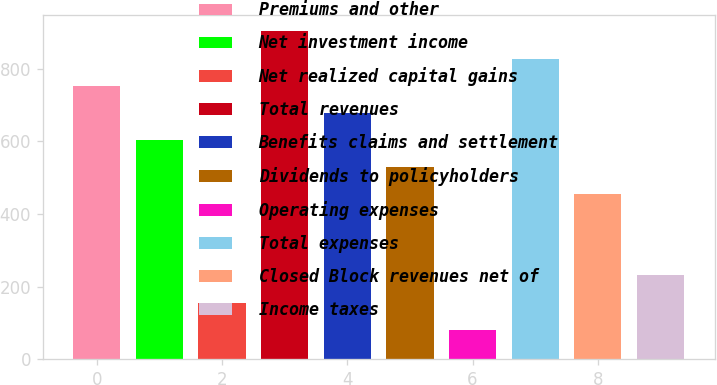Convert chart. <chart><loc_0><loc_0><loc_500><loc_500><bar_chart><fcel>Premiums and other<fcel>Net investment income<fcel>Net realized capital gains<fcel>Total revenues<fcel>Benefits claims and settlement<fcel>Dividends to policyholders<fcel>Operating expenses<fcel>Total expenses<fcel>Closed Block revenues net of<fcel>Income taxes<nl><fcel>753.7<fcel>604.28<fcel>156.02<fcel>903.12<fcel>678.99<fcel>529.57<fcel>81.31<fcel>828.41<fcel>454.86<fcel>230.73<nl></chart> 